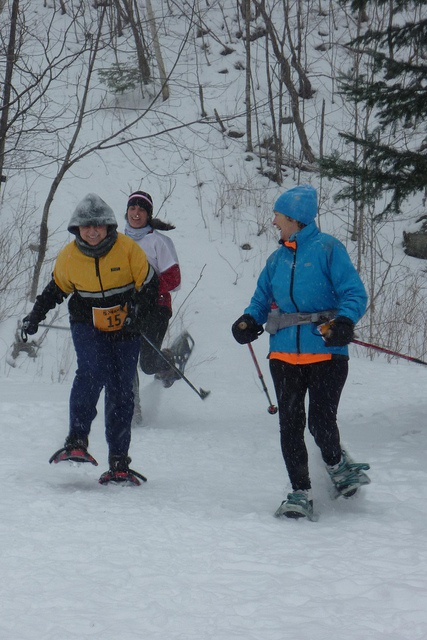Describe the objects in this image and their specific colors. I can see people in gray, black, and blue tones, people in gray, black, olive, and darkgray tones, and people in gray, black, darkgray, and maroon tones in this image. 